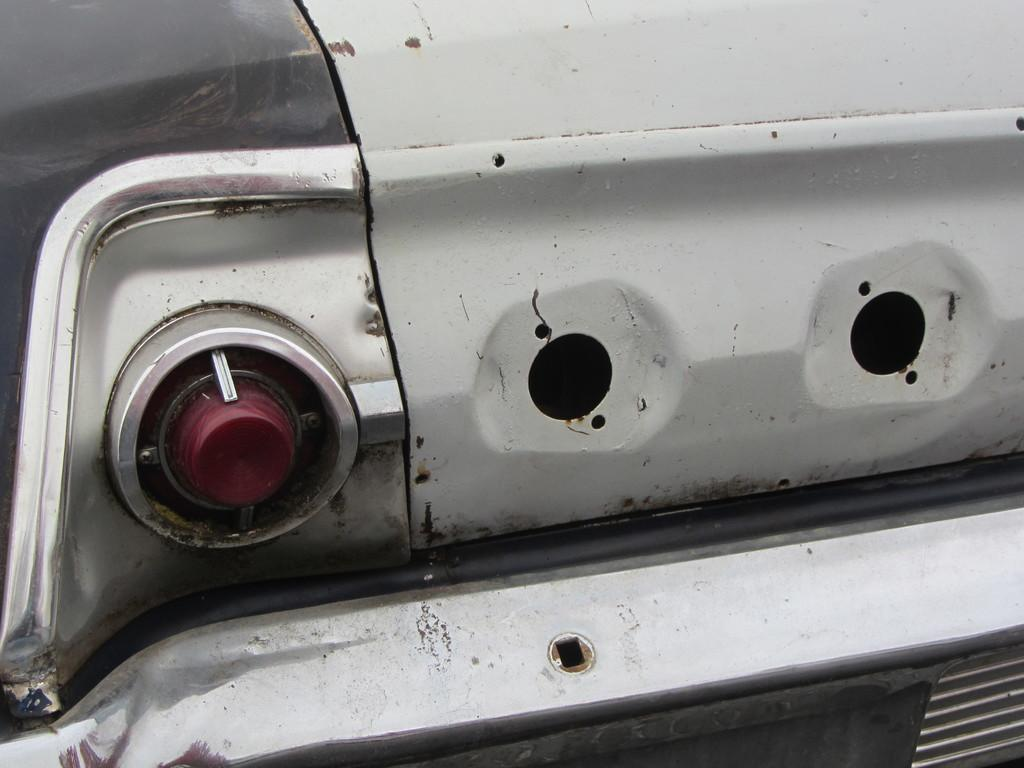What is the main subject of the image? The main subject of the image is a car. Can you describe any specific features of the car? Yes, the car has a tail light. What type of food is the car cooking in the image? There is no food or cooking activity present in the image; it features a car with a tail light. How many people are pushing the car in the image? There is no indication in the image that the car is being pushed or that there are any people involved in such an activity. 